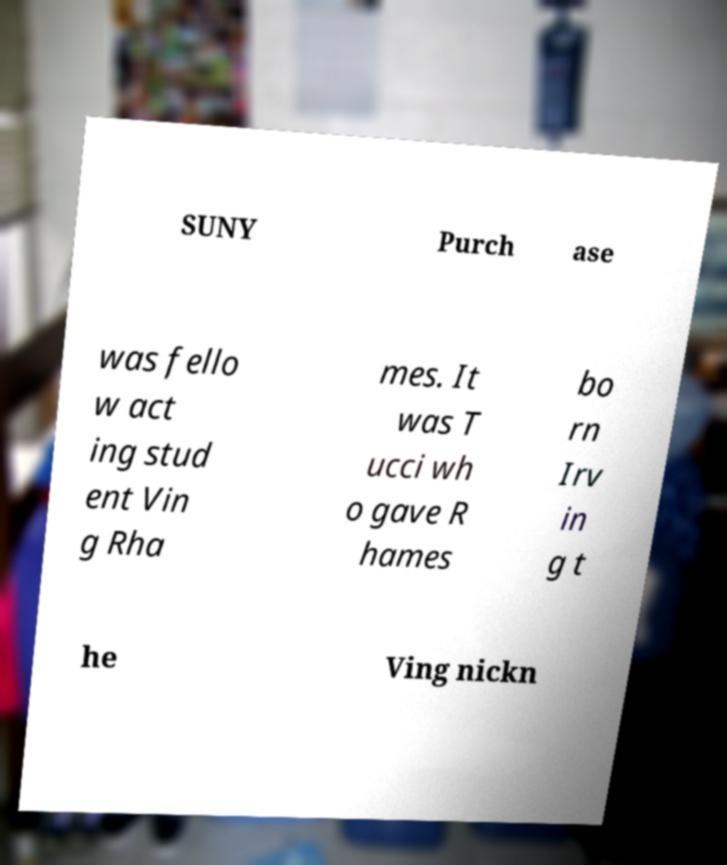Please identify and transcribe the text found in this image. SUNY Purch ase was fello w act ing stud ent Vin g Rha mes. It was T ucci wh o gave R hames bo rn Irv in g t he Ving nickn 